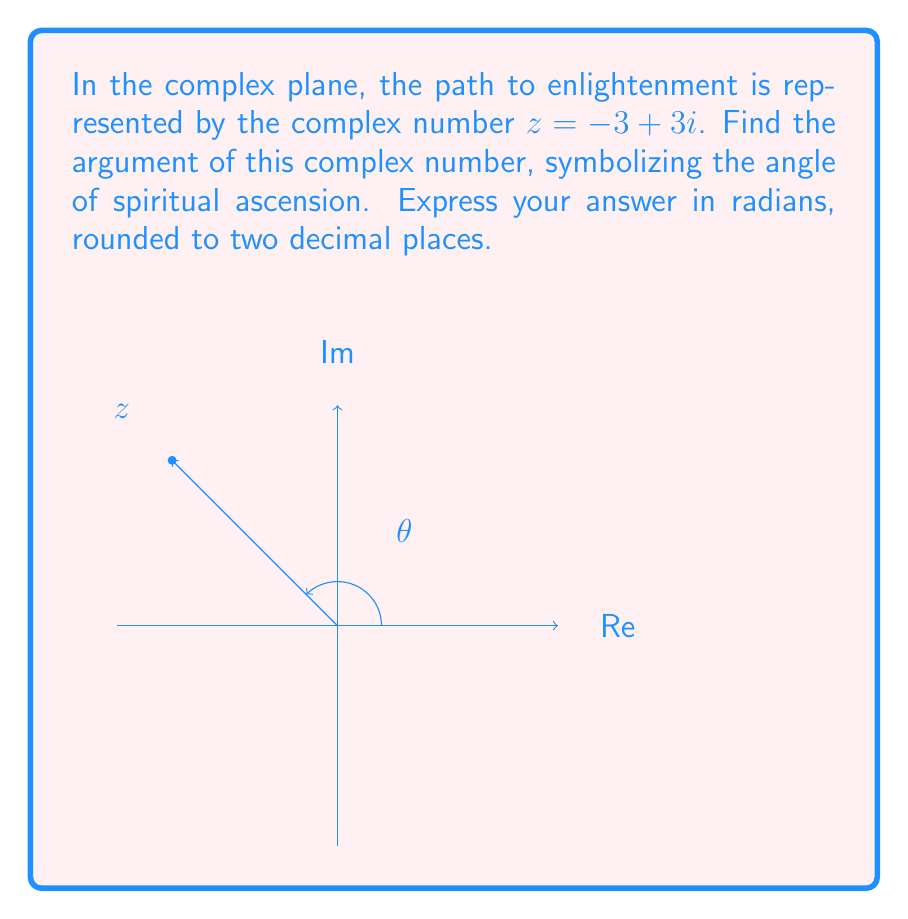Can you solve this math problem? To find the argument of a complex number $z = a + bi$, we use the arctangent function:

$$\theta = \arctan(\frac{b}{a})$$

However, we need to be careful about which quadrant the complex number is in. For $z = -3 + 3i$:

1) First, identify the quadrant: $z$ is in the second quadrant (negative real part, positive imaginary part).

2) Calculate the basic arctangent:
   $$\arctan(\frac{3}{-3}) = \arctan(-1) = -\frac{\pi}{4} \approx -0.7854$$

3) For the second quadrant, we need to add $\pi$ to this result:
   $$-\frac{\pi}{4} + \pi = \frac{3\pi}{4} \approx 2.3562$$

4) Rounding to two decimal places:
   $$\frac{3\pi}{4} \approx 2.36$$

This angle represents the direction of the path to enlightenment in the complex plane, symbolizing the journey from the material world (real axis) towards spiritual realms (imaginary axis).
Answer: $2.36$ radians 